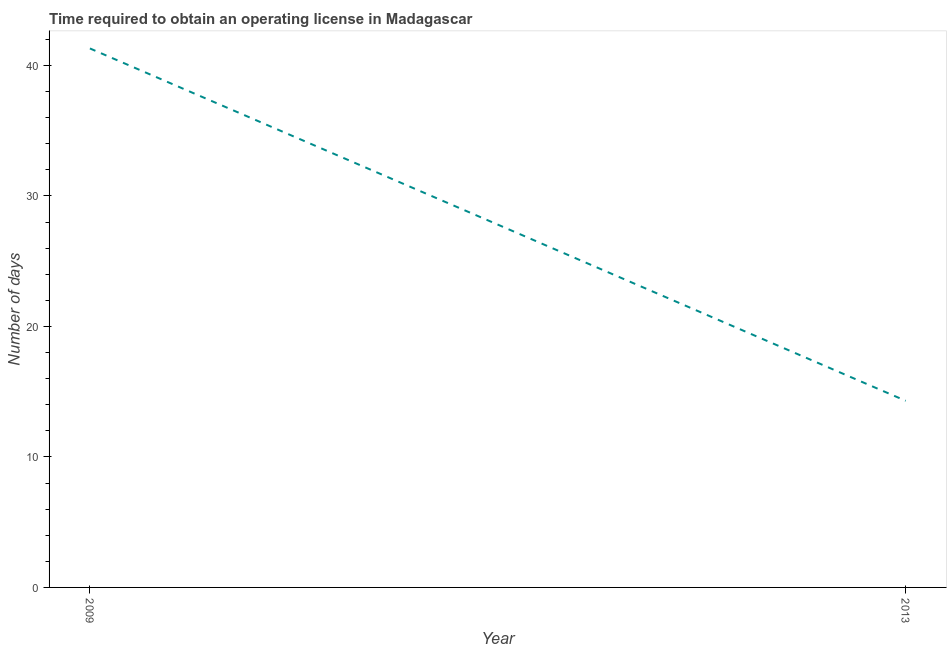What is the number of days to obtain operating license in 2009?
Offer a terse response. 41.3. Across all years, what is the maximum number of days to obtain operating license?
Your answer should be compact. 41.3. Across all years, what is the minimum number of days to obtain operating license?
Provide a succinct answer. 14.3. In which year was the number of days to obtain operating license maximum?
Your response must be concise. 2009. In which year was the number of days to obtain operating license minimum?
Provide a succinct answer. 2013. What is the sum of the number of days to obtain operating license?
Your answer should be very brief. 55.6. What is the difference between the number of days to obtain operating license in 2009 and 2013?
Your response must be concise. 27. What is the average number of days to obtain operating license per year?
Provide a succinct answer. 27.8. What is the median number of days to obtain operating license?
Your answer should be compact. 27.8. What is the ratio of the number of days to obtain operating license in 2009 to that in 2013?
Your response must be concise. 2.89. Is the number of days to obtain operating license in 2009 less than that in 2013?
Your answer should be compact. No. In how many years, is the number of days to obtain operating license greater than the average number of days to obtain operating license taken over all years?
Offer a terse response. 1. What is the difference between two consecutive major ticks on the Y-axis?
Provide a succinct answer. 10. Are the values on the major ticks of Y-axis written in scientific E-notation?
Your answer should be very brief. No. What is the title of the graph?
Make the answer very short. Time required to obtain an operating license in Madagascar. What is the label or title of the Y-axis?
Offer a terse response. Number of days. What is the Number of days in 2009?
Your answer should be compact. 41.3. What is the ratio of the Number of days in 2009 to that in 2013?
Make the answer very short. 2.89. 